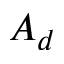<formula> <loc_0><loc_0><loc_500><loc_500>A _ { d }</formula> 